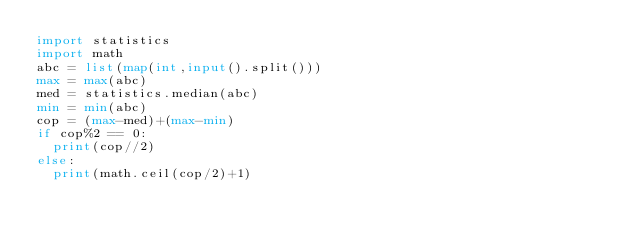<code> <loc_0><loc_0><loc_500><loc_500><_Python_>import statistics
import math
abc = list(map(int,input().split()))
max = max(abc)
med = statistics.median(abc)
min = min(abc)
cop = (max-med)+(max-min)
if cop%2 == 0:
	print(cop//2)
else:
	print(math.ceil(cop/2)+1)</code> 